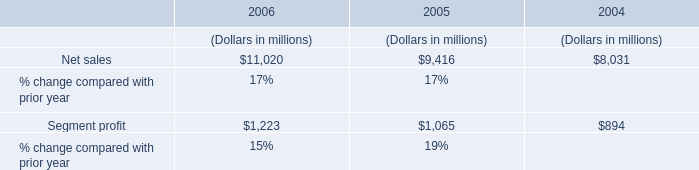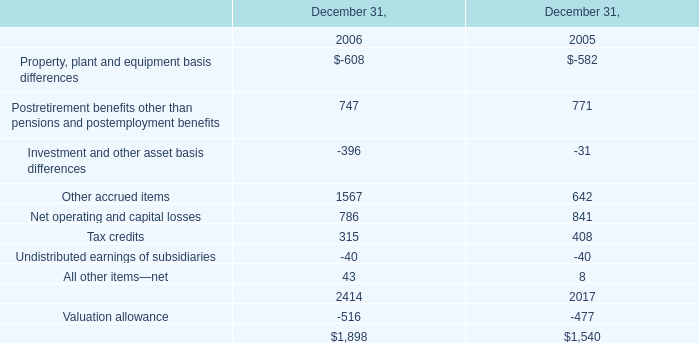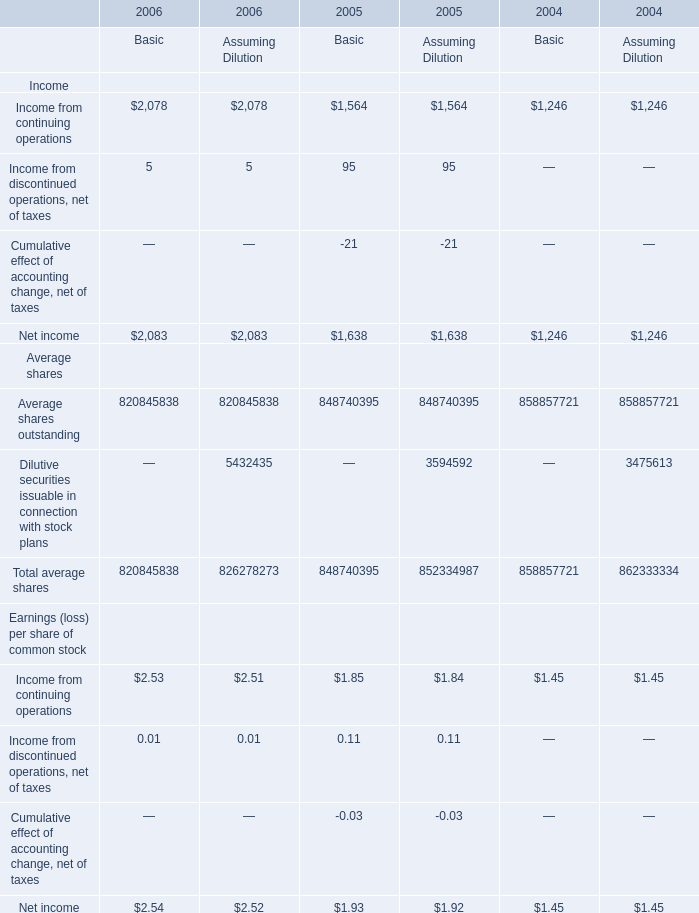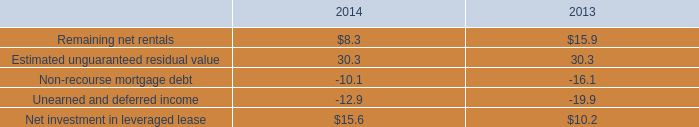at december 31 , 2014 what was the amount of the equity in millions for the , ground-up development vie in millions . 
Computations: (77.7 - 0.1)
Answer: 77.6. 